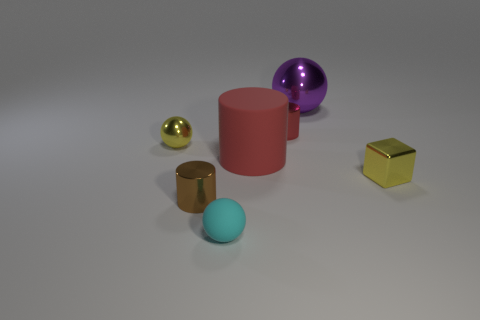Are there any big red matte things of the same shape as the small cyan matte object?
Your response must be concise. No. There is a ball that is behind the yellow shiny block and in front of the tiny red cylinder; what material is it?
Provide a short and direct response. Metal. Is there a object that is on the right side of the small ball in front of the metallic cube?
Offer a very short reply. Yes. Is the material of the big purple ball the same as the yellow sphere?
Offer a terse response. Yes. What is the shape of the small object that is behind the small brown thing and on the left side of the small rubber thing?
Make the answer very short. Sphere. What size is the red cylinder in front of the tiny cylinder behind the large rubber thing?
Keep it short and to the point. Large. What number of large purple metal objects have the same shape as the brown shiny object?
Offer a terse response. 0. Is the small rubber sphere the same color as the rubber cylinder?
Your answer should be very brief. No. Is there anything else that has the same shape as the brown object?
Ensure brevity in your answer.  Yes. Are there any big metallic spheres that have the same color as the small rubber thing?
Keep it short and to the point. No. 